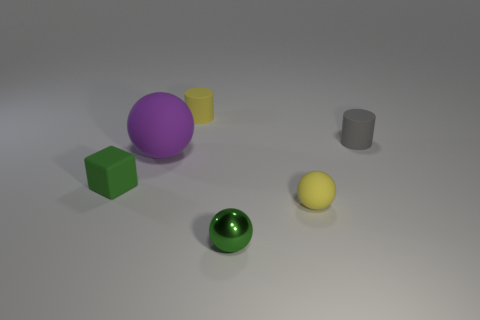The other cylinder that is the same material as the gray cylinder is what size?
Provide a short and direct response. Small. How many green objects are tiny shiny spheres or large matte objects?
Your response must be concise. 1. What is the shape of the matte thing that is the same color as the shiny thing?
Offer a very short reply. Cube. Is there anything else that has the same material as the small gray cylinder?
Offer a terse response. Yes. There is a yellow rubber thing that is to the right of the tiny metallic sphere; does it have the same shape as the yellow thing behind the purple object?
Keep it short and to the point. No. How many metallic objects are there?
Your answer should be compact. 1. What is the shape of the tiny green thing that is the same material as the purple sphere?
Make the answer very short. Cube. Is there any other thing that is the same color as the metal object?
Offer a very short reply. Yes. Do the big matte object and the small thing on the left side of the large purple object have the same color?
Your answer should be very brief. No. Is the number of small green matte objects that are in front of the green shiny ball less than the number of tiny matte things?
Ensure brevity in your answer.  Yes. 